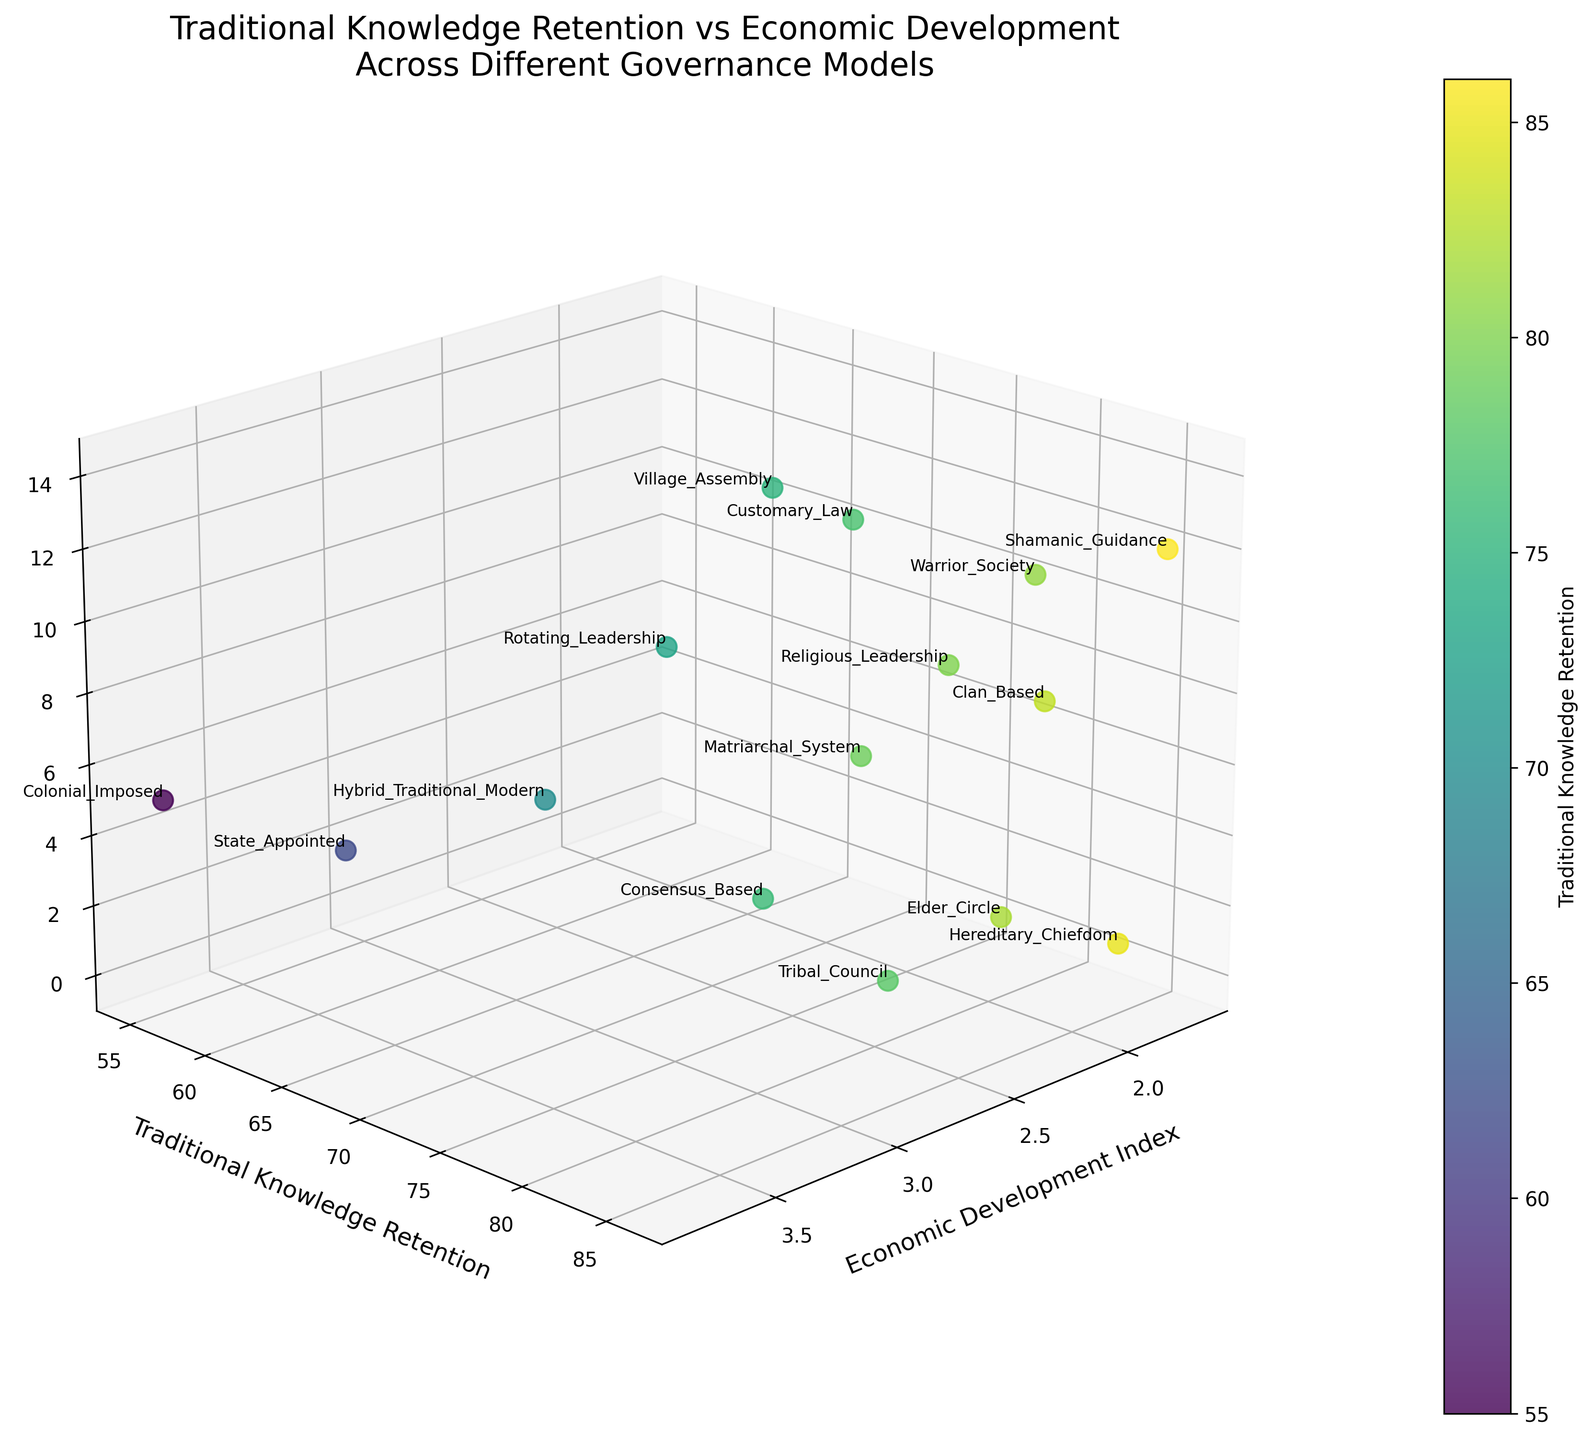What is the title of the plot? The title is usually placed at the top of the plot and is often used to describe the main theme or subject of the data presented.
Answer: Traditional Knowledge Retention vs Economic Development Across Different Governance Models How many governance models are represented in the plot? To find the number of governance models, count the number of distinct labels in the figure.
Answer: 15 Which governance model has the highest traditional knowledge retention? Look for the data point with the highest "Traditional Knowledge Retention" value and note the associated governance model label.
Answer: Shamanic Guidance Which governance model has the lowest traditional knowledge retention? Look for the data point with the lowest "Traditional Knowledge Retention" value and note the associated governance model label.
Answer: Colonial Imposed What color represents higher traditional knowledge retention in the color bar? Observe the color bar next to the plot. Darker or more intense colors typically represent higher values based on the viridis colormap used.
Answer: Dark green Which governance model is associated with an Economic Development Index of approximately 2.0? Locate the x-axis value closest to 2.0 and identify the governance model associated with it.
Answer: Clan Based How does traditional knowledge retention change with increasing economic development index? Observe the general trend of the points as you move from lower to higher values on the Economic Development Index axis.
Answer: Generally decreases Are there any governance models with both high traditional knowledge retention and high economic development? Cross-reference data points with both high "Traditional Knowledge Retention" and high "Economic Development Index" values.
Answer: No What is the Economic Development Index range observed in the plot? Find the minimum and maximum values on the Economic Development Index (x-axis) to determine the range.
Answer: 1.7 to 3.8 Is there any governance model that has an economic development index around 3.5 and a traditional knowledge retention around 62? If so, which one? Locate the point closest to x=3.5 and y=62, then identify its label.
Answer: State Appointed 